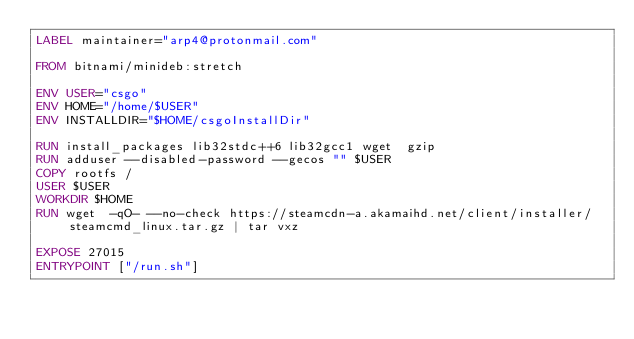<code> <loc_0><loc_0><loc_500><loc_500><_Dockerfile_>LABEL maintainer="arp4@protonmail.com"

FROM bitnami/minideb:stretch

ENV USER="csgo"  
ENV HOME="/home/$USER" 
ENV INSTALLDIR="$HOME/csgoInstallDir"

RUN install_packages lib32stdc++6 lib32gcc1 wget  gzip
RUN adduser --disabled-password --gecos "" $USER  
COPY rootfs /
USER $USER
WORKDIR $HOME
RUN wget  -qO- --no-check https://steamcdn-a.akamaihd.net/client/installer/steamcmd_linux.tar.gz | tar vxz

EXPOSE 27015
ENTRYPOINT ["/run.sh"]
</code> 